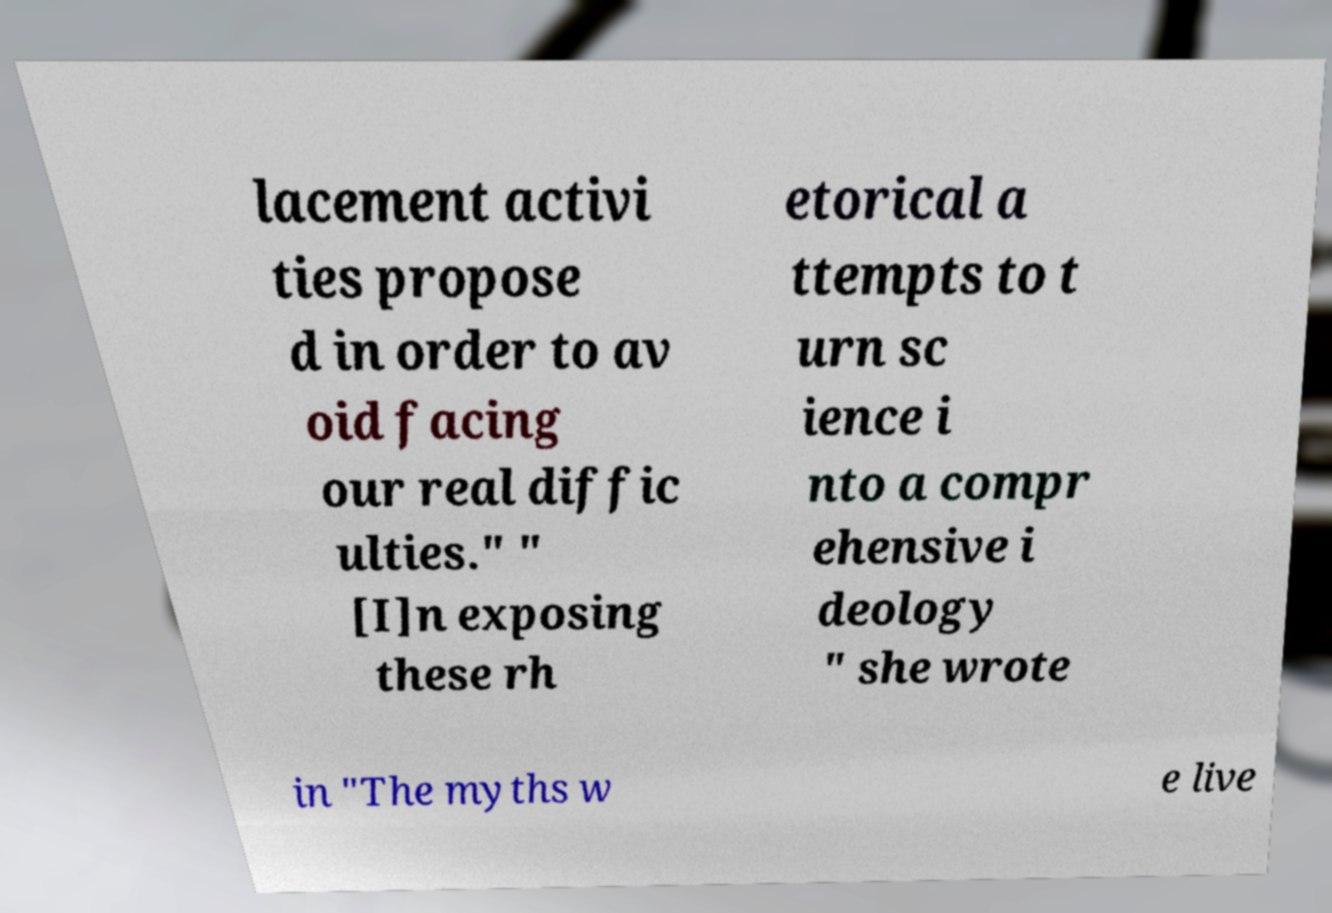For documentation purposes, I need the text within this image transcribed. Could you provide that? lacement activi ties propose d in order to av oid facing our real diffic ulties." " [I]n exposing these rh etorical a ttempts to t urn sc ience i nto a compr ehensive i deology " she wrote in "The myths w e live 